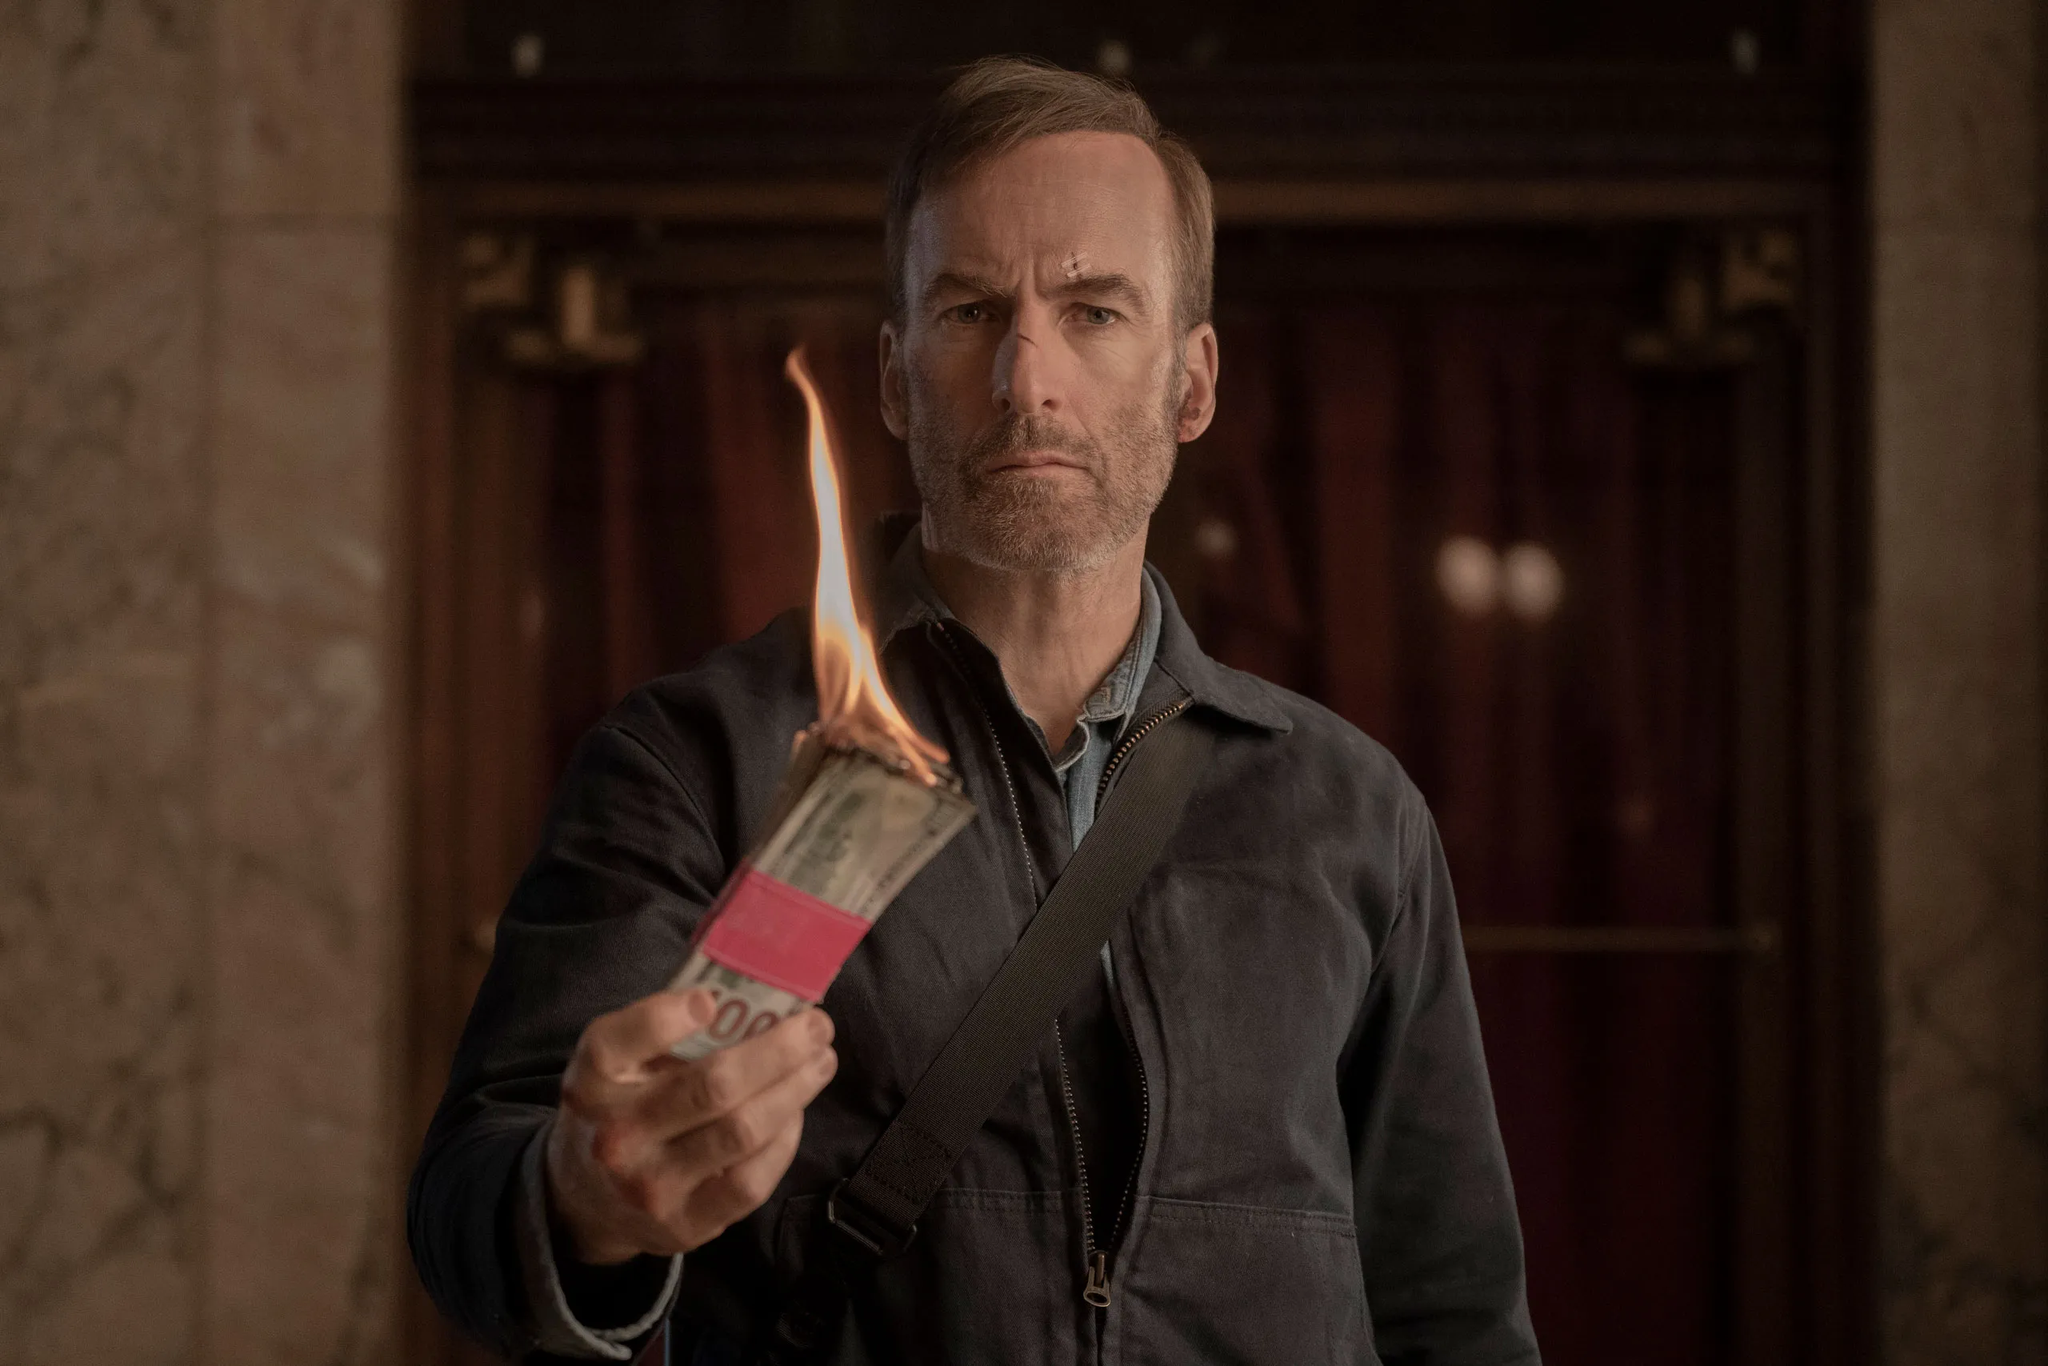Write a detailed description of the given image. In the image, the actor is depicted in a moment filled with tension and seriousness. He stands in front of a wooden door, the dimly lit hallway or lobby of a building as his backdrop. Dressed in a gray jacket, he carries a black bag over his left shoulder. The most captivating element is the burning stack of dollar bills he holds in his right hand, with the flame casting an intense, eerie glow on his face. His expression is stern and relaxed, suggesting the gravity of the situation he's involved in and possibly highlighting a key moment in a dramatic narrative. 